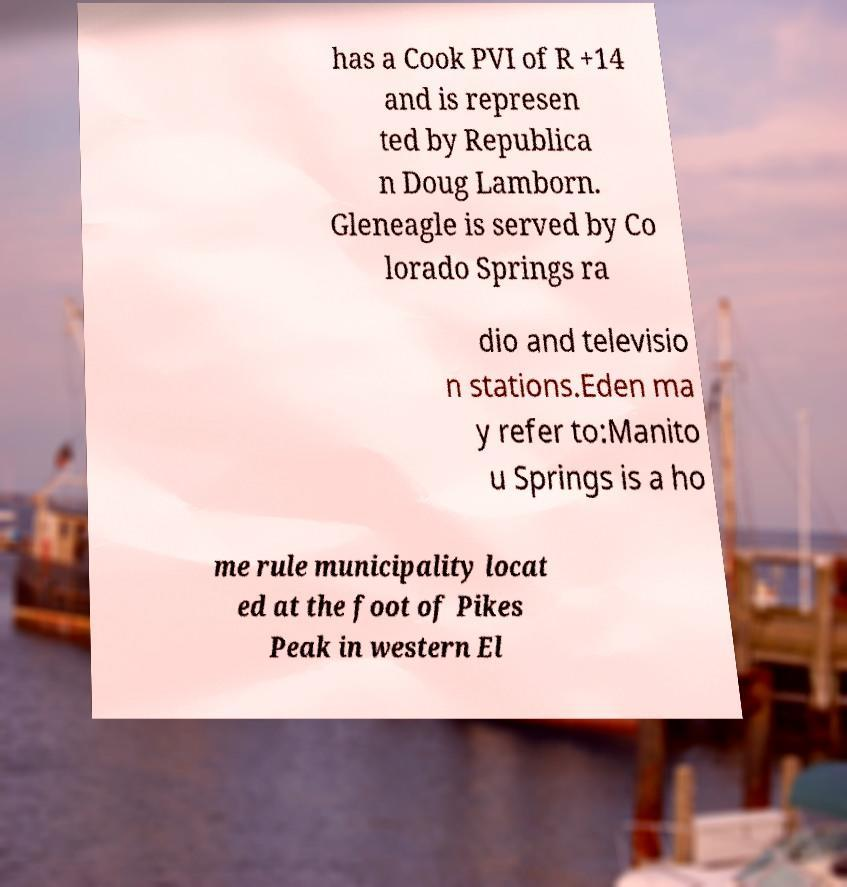Could you assist in decoding the text presented in this image and type it out clearly? has a Cook PVI of R +14 and is represen ted by Republica n Doug Lamborn. Gleneagle is served by Co lorado Springs ra dio and televisio n stations.Eden ma y refer to:Manito u Springs is a ho me rule municipality locat ed at the foot of Pikes Peak in western El 